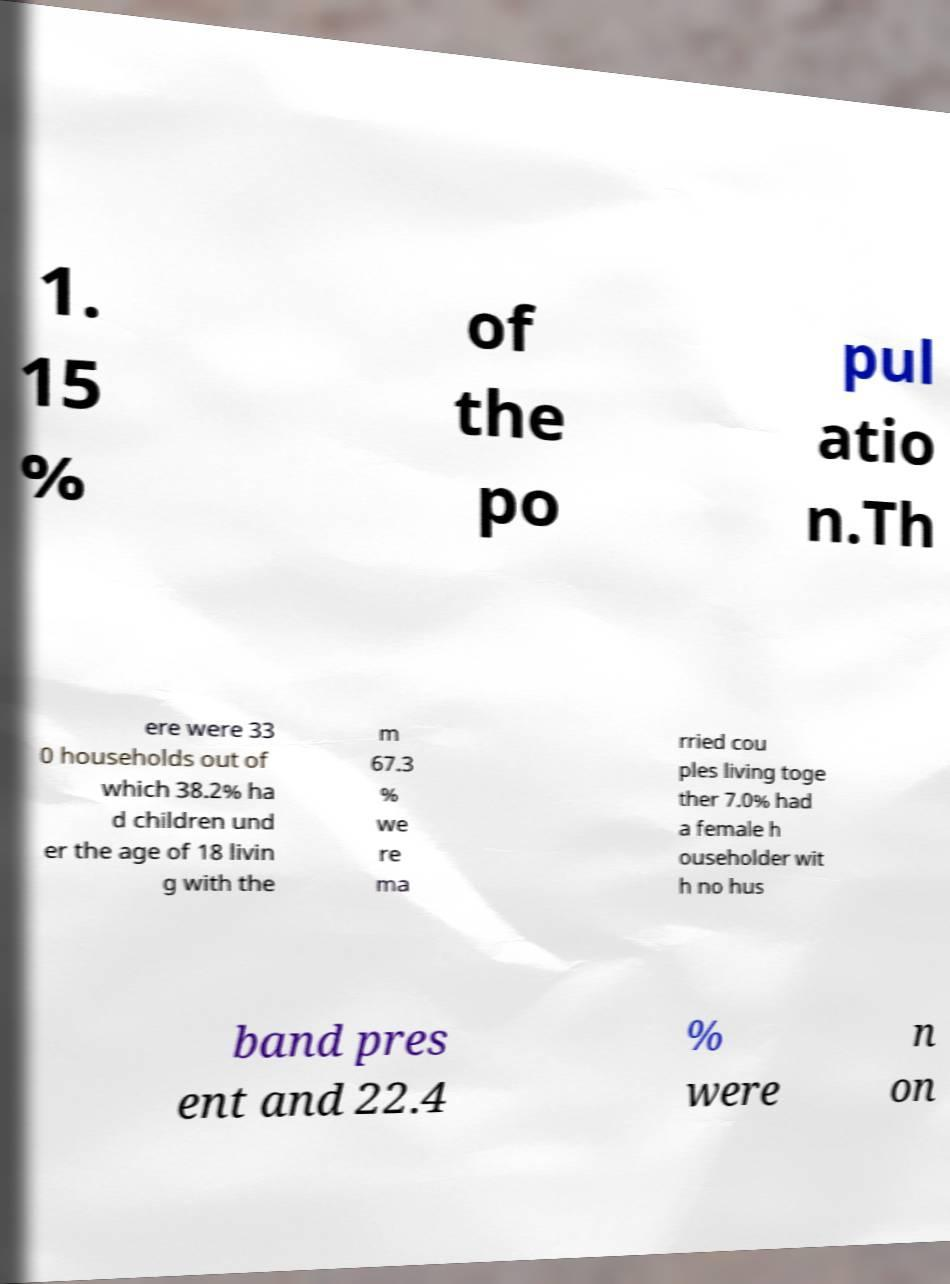For documentation purposes, I need the text within this image transcribed. Could you provide that? 1. 15 % of the po pul atio n.Th ere were 33 0 households out of which 38.2% ha d children und er the age of 18 livin g with the m 67.3 % we re ma rried cou ples living toge ther 7.0% had a female h ouseholder wit h no hus band pres ent and 22.4 % were n on 